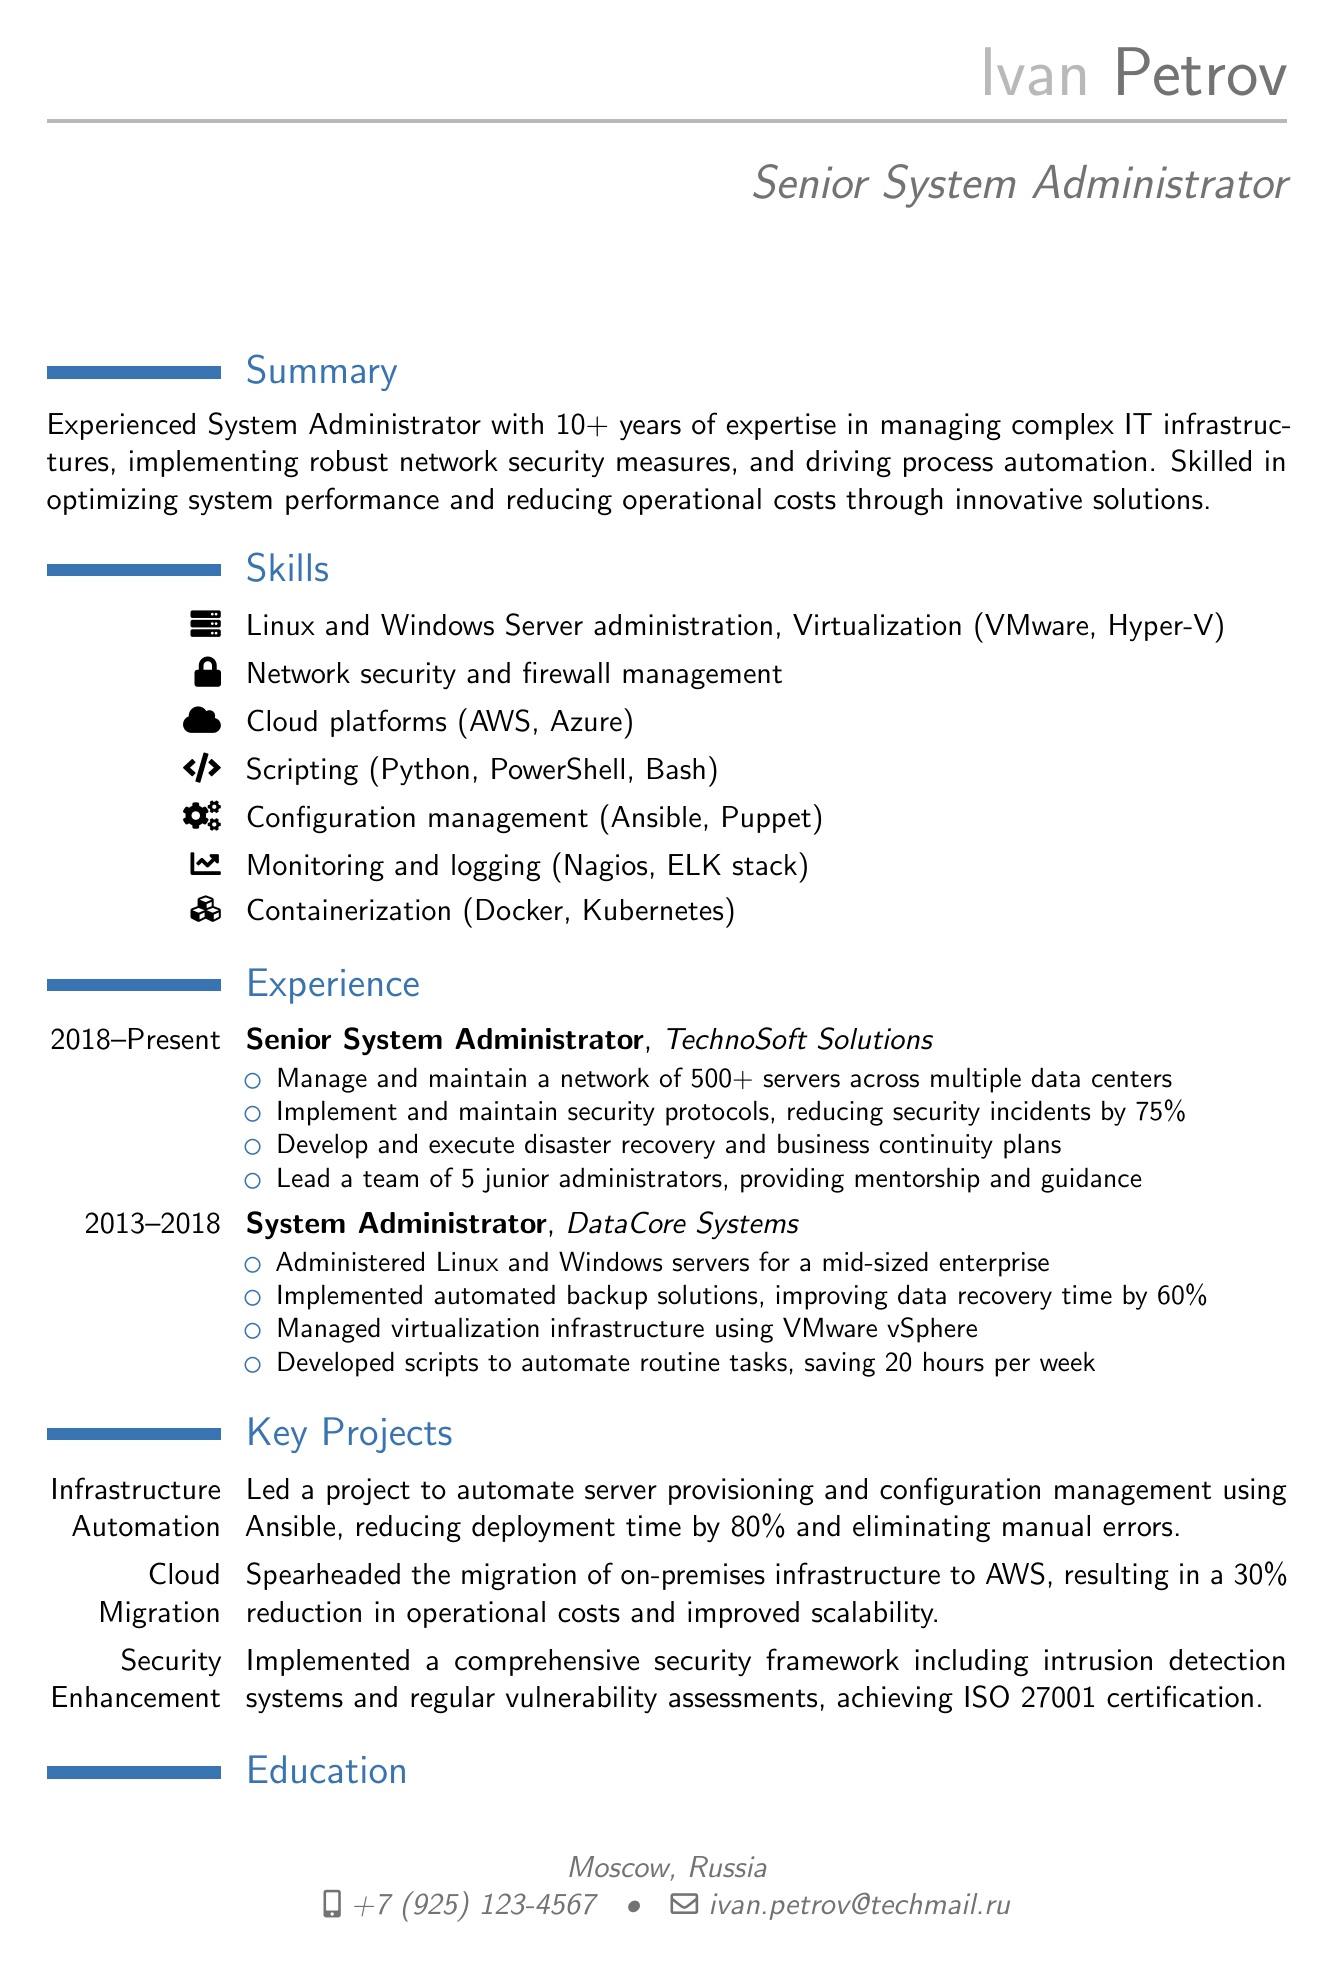what is the name of the individual? The name is provided in the personal information section of the document as Ivan Petrov.
Answer: Ivan Petrov what is the title of the CV? The title for this individual's role is clearly stated as Senior System Administrator.
Answer: Senior System Administrator how many years of experience does he have? The summary mentions that he has over 10 years of expertise in system administration.
Answer: 10+ which company did he work for from 2013 to 2018? The experience section lists DataCore Systems as the company where he worked during that period.
Answer: DataCore Systems what was the reduction in security incidents due to implemented security protocols? The document states that security incidents were reduced by 75%.
Answer: 75% name one of the certifications he holds. The certifications section lists several certifications, one of which is Red Hat Certified Engineer (RHCE).
Answer: Red Hat Certified Engineer (RHCE) what was the impact of the cloud migration project? The document notes that it resulted in a 30% reduction in operational costs.
Answer: 30% how many servers does he manage in his current position? It is stated that he manages and maintains a network of 500+ servers.
Answer: 500+ what scripting languages is he skilled in? The skills section enumerates Python, PowerShell, and Bash as his scripting languages.
Answer: Python, PowerShell, Bash 